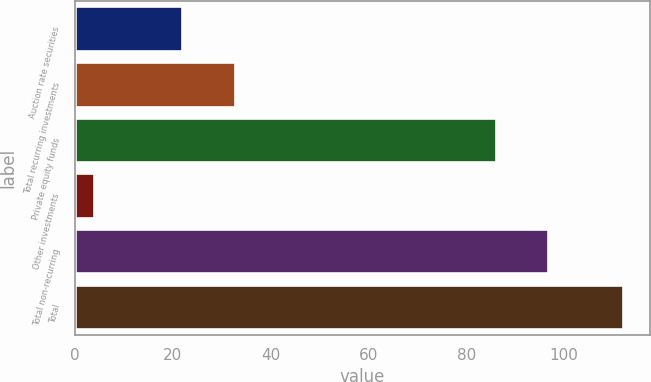Convert chart. <chart><loc_0><loc_0><loc_500><loc_500><bar_chart><fcel>Auction rate securities<fcel>Total recurring investments<fcel>Private equity funds<fcel>Other investments<fcel>Total non-recurring<fcel>Total<nl><fcel>22<fcel>32.8<fcel>86<fcel>4<fcel>96.8<fcel>112<nl></chart> 